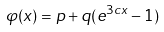Convert formula to latex. <formula><loc_0><loc_0><loc_500><loc_500>\varphi ( x ) = p + q ( e ^ { 3 c x } - 1 )</formula> 